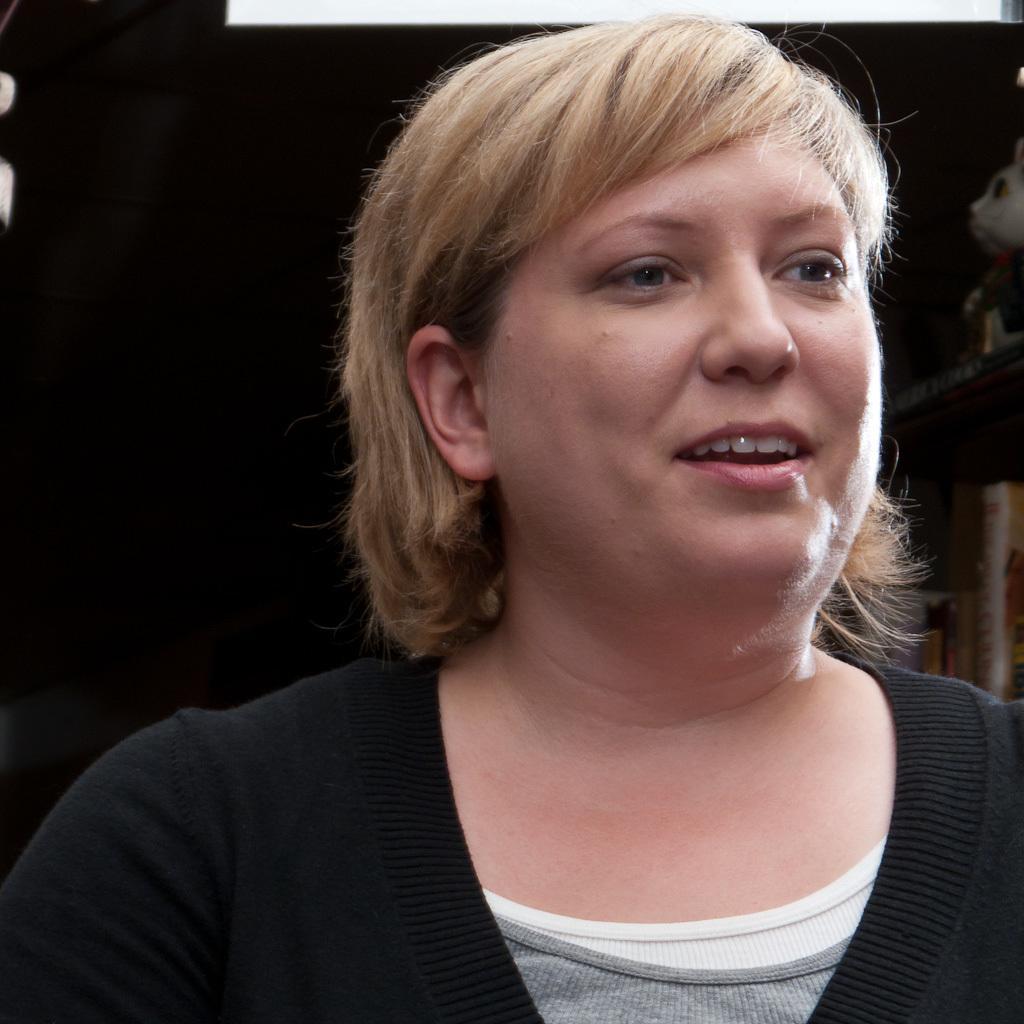Please provide a concise description of this image. In this image there is a picture of a woman. 